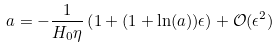<formula> <loc_0><loc_0><loc_500><loc_500>a = - \frac { 1 } { H _ { 0 } \eta } \left ( 1 + ( 1 + \ln ( a ) ) \epsilon \right ) + \mathcal { O } ( \epsilon ^ { 2 } )</formula> 